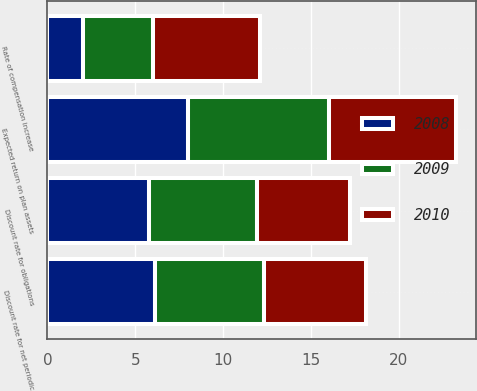Convert chart. <chart><loc_0><loc_0><loc_500><loc_500><stacked_bar_chart><ecel><fcel>Discount rate for obligations<fcel>Expected return on plan assets<fcel>Rate of compensation increase<fcel>Discount rate for net periodic<nl><fcel>2010<fcel>5.3<fcel>7.25<fcel>6.1<fcel>5.8<nl><fcel>2008<fcel>5.8<fcel>8<fcel>2<fcel>6.1<nl><fcel>2009<fcel>6.1<fcel>8<fcel>4<fcel>6.25<nl></chart> 